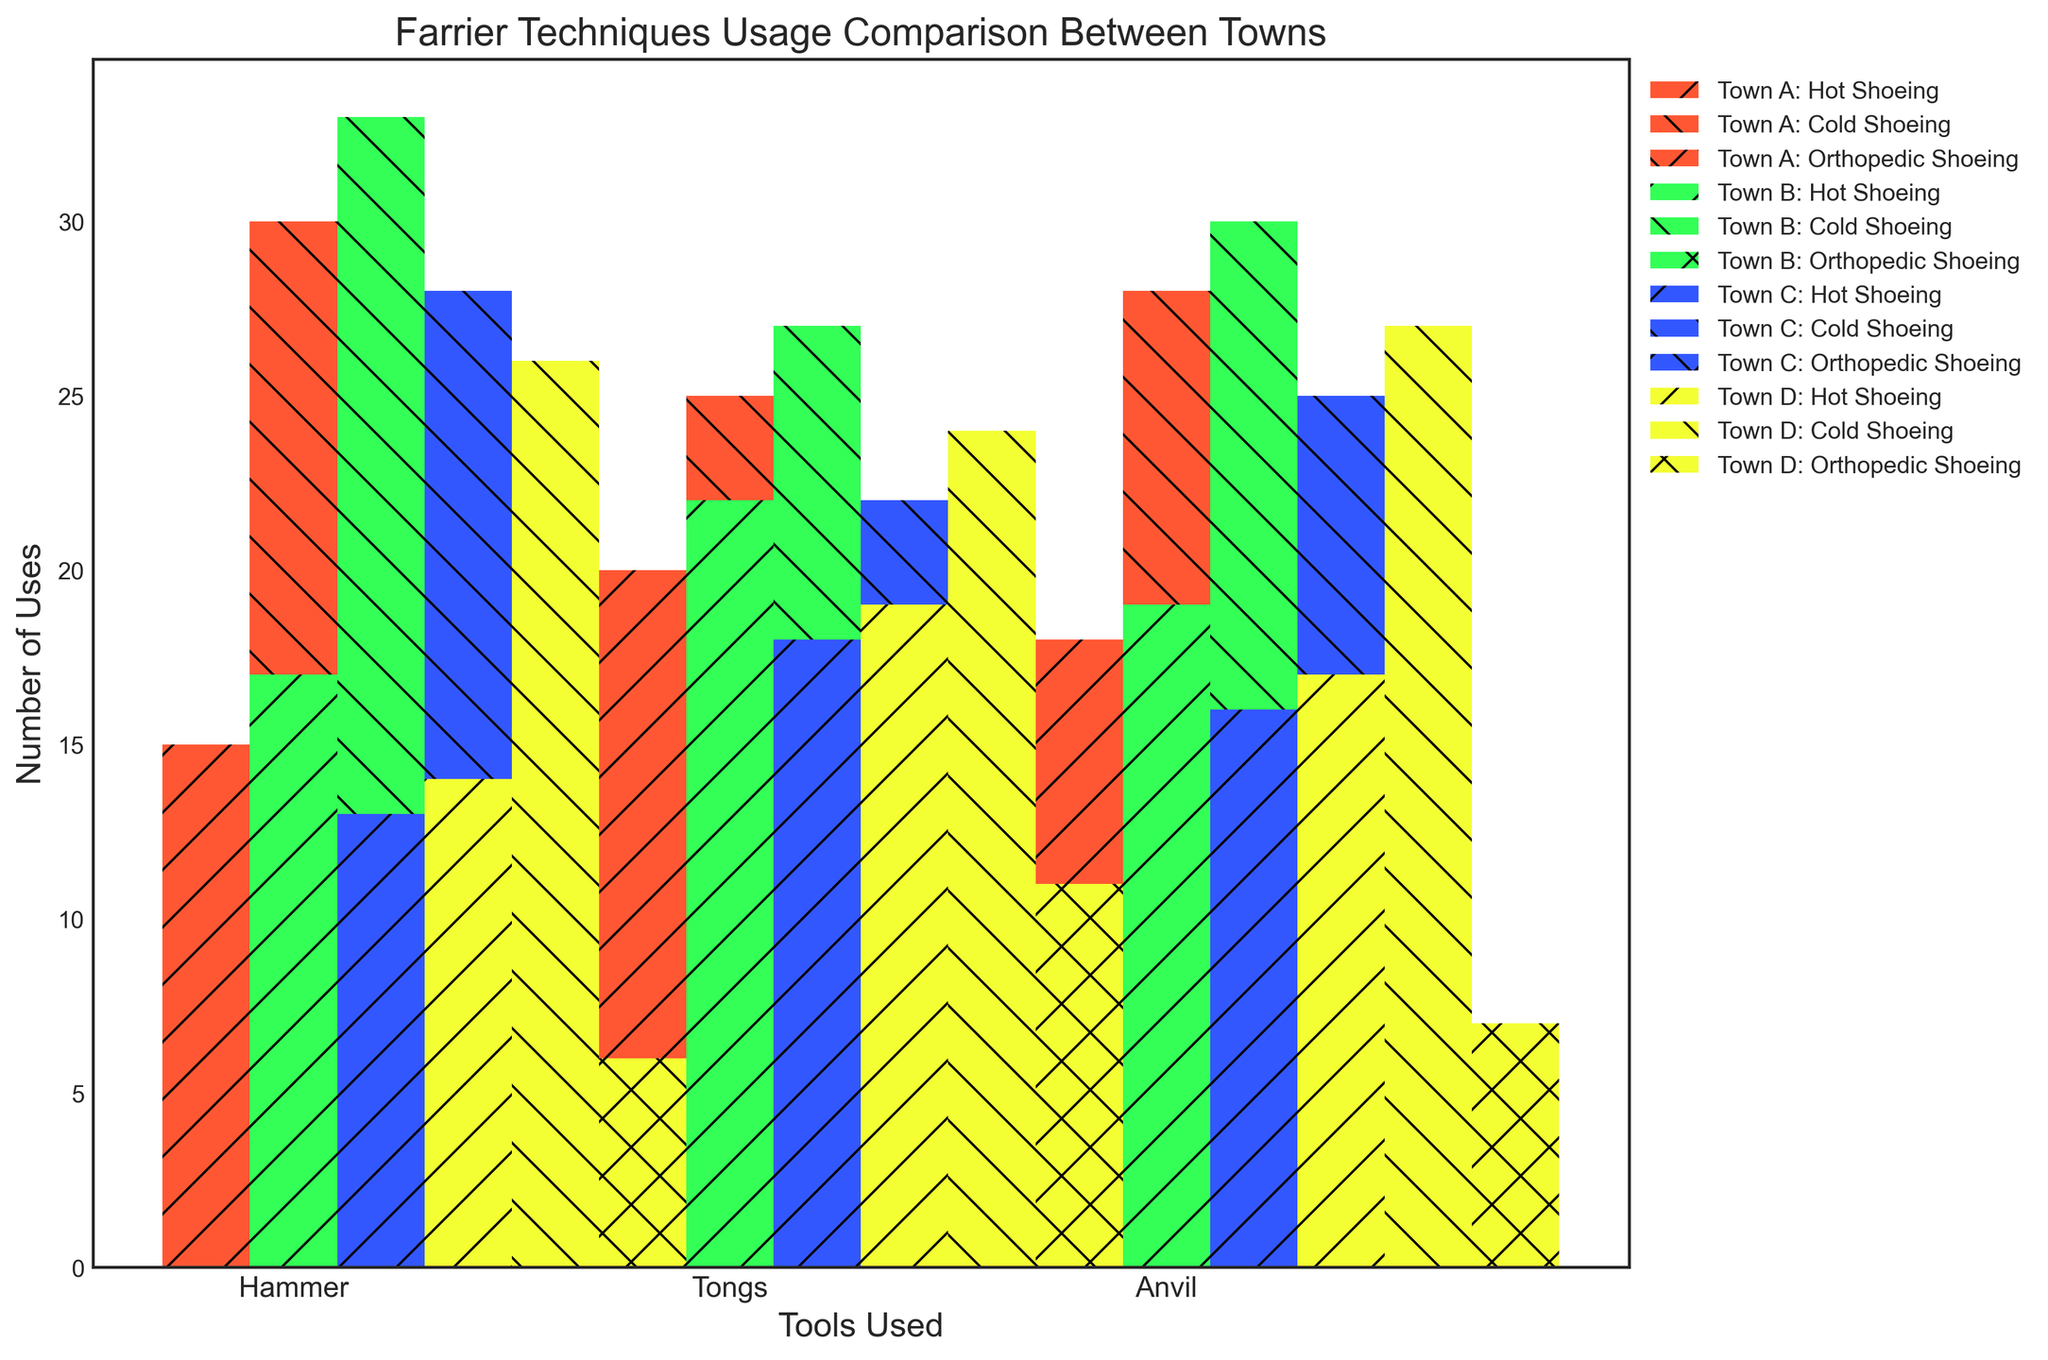Which town uses the hammer the most for hot shoeing? Look at the bar corresponding to the hammer under the Hot Shoeing category for each town; Town B has the highest bar at 17 uses.
Answer: Town B What's the total number of cold shoeing instances using anvils across all towns? Sum the values for cold shoeing using anvils in all towns: 28 (Town A) + 30 (Town B) + 25 (Town C) + 27 (Town D) = 110.
Answer: 110 Which tool is used the least for orthopedic shoeing in Town C? Compare the bars for orthopedic shoeing in Town C; the hammer has the lowest bar with 4 uses.
Answer: Hammer Is the use of tongs for hot shoeing greater in Town B than in Town C? Compare the bars for hot shoeing using tongs between Town B (22 uses) and Town C (18 uses); it's higher in Town B.
Answer: Yes What is the combined usage of anvils for hot shoeing and cold shoeing in Town D? Add the hot shoeing and cold shoeing values for anvils in Town D: 17 (hot) + 27 (cold) = 44.
Answer: 44 What's the difference in usage of tongs for orthopedic shoeing between Town A and Town D? Subtract the usage of tongs for orthopedic shoeing in Town A (10) from Town D (11): 11 - 10 = 1.
Answer: 1 Which town has the highest total usage of the hammer for all techniques? Sum the hammer usage for all techniques in each town: Town A (50), Town B (57), Town C (45), Town D (46); Town B has the highest with 57.
Answer: Town B Is the number of orthopedic shoeing instances using anvils greater than using hammers in Town B? Compare the bars for orthopedic shoeing using anvils (8) and hammers (7) in Town B: 8 is greater than 7.
Answer: Yes What is the average number of uses of tongs for hot shoeing across all towns? Add the number of uses of tongs for hot shoeing in all towns and divide by the number of towns: (20 + 22 + 18 + 19) / 4 = 19.75.
Answer: 19.75 Which town shows the least variation in the use of tools for cold shoeing? Compare the bars for cold shoeing for each tool in each town and assess the differences: Town C has the smallest range (28, 22, 25), showing the least variation (range = 6).
Answer: Town C 